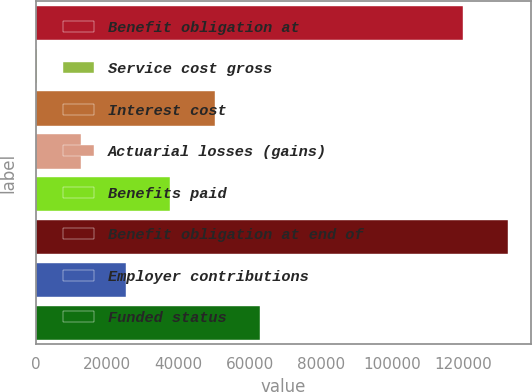Convert chart to OTSL. <chart><loc_0><loc_0><loc_500><loc_500><bar_chart><fcel>Benefit obligation at<fcel>Service cost gross<fcel>Interest cost<fcel>Actuarial losses (gains)<fcel>Benefits paid<fcel>Benefit obligation at end of<fcel>Employer contributions<fcel>Funded status<nl><fcel>119930<fcel>264<fcel>50294.4<fcel>12771.6<fcel>37786.8<fcel>132438<fcel>25279.2<fcel>62802<nl></chart> 